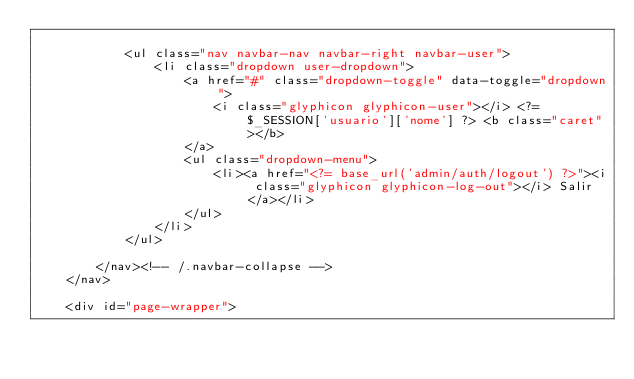Convert code to text. <code><loc_0><loc_0><loc_500><loc_500><_PHP_>
			<ul class="nav navbar-nav navbar-right navbar-user">
				<li class="dropdown user-dropdown">
					<a href="#" class="dropdown-toggle" data-toggle="dropdown">
						<i class="glyphicon glyphicon-user"></i> <?= $_SESSION['usuario']['nome'] ?> <b class="caret"></b>
					</a>
					<ul class="dropdown-menu">
						<li><a href="<?= base_url('admin/auth/logout') ?>"><i class="glyphicon glyphicon-log-out"></i> Salir</a></li>
					</ul>
				</li>
			</ul>

		</nav><!-- /.navbar-collapse -->
	</nav>

	<div id="page-wrapper">
</code> 